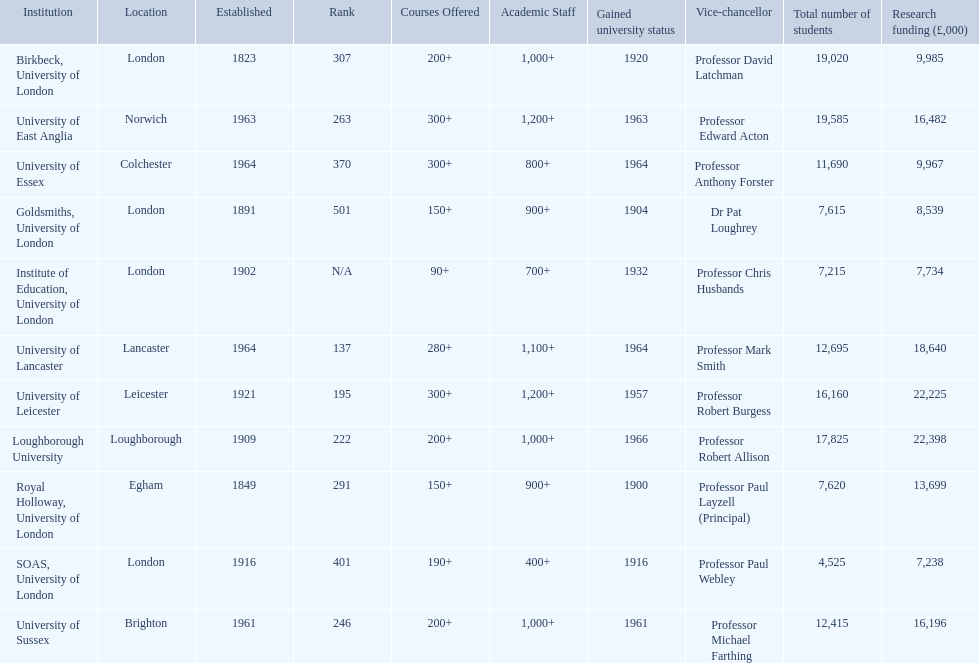What are the institutions in the 1994 group? Birkbeck, University of London, University of East Anglia, University of Essex, Goldsmiths, University of London, Institute of Education, University of London, University of Lancaster, University of Leicester, Loughborough University, Royal Holloway, University of London, SOAS, University of London, University of Sussex. Which of these was made a university most recently? Loughborough University. 